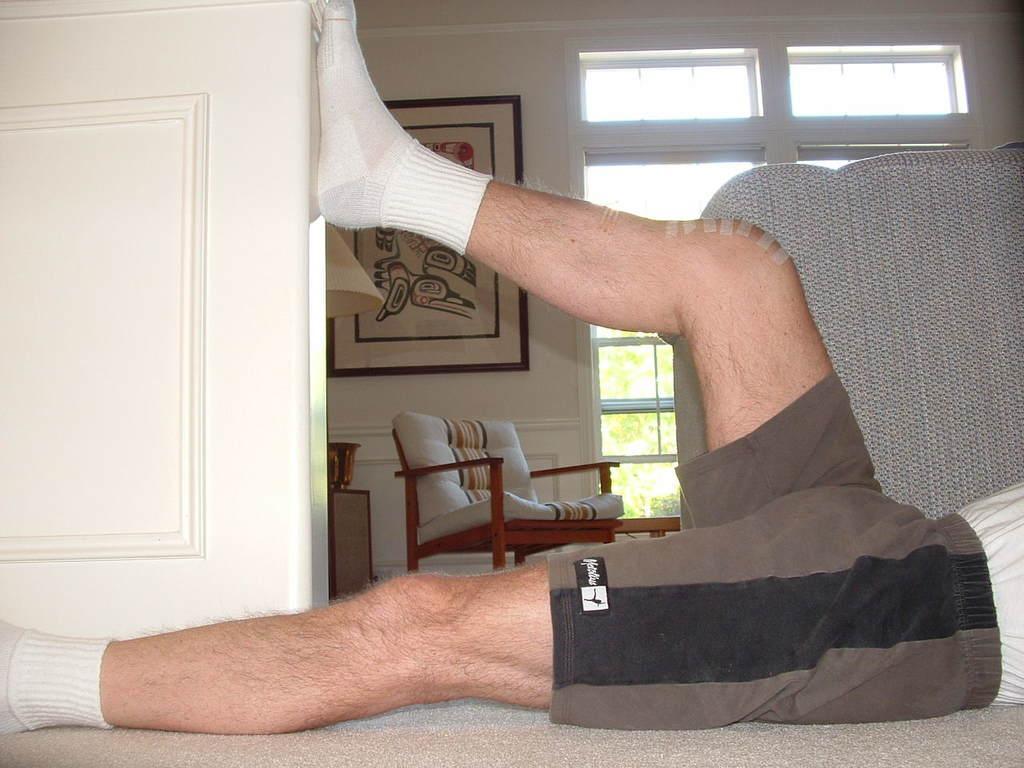In one or two sentences, can you explain what this image depicts? In this image I can see a person is lying on the floor. In the background I can see a sofa, chair, window, trees, wall, wall painting and a door. This image is taken may be in a room. 